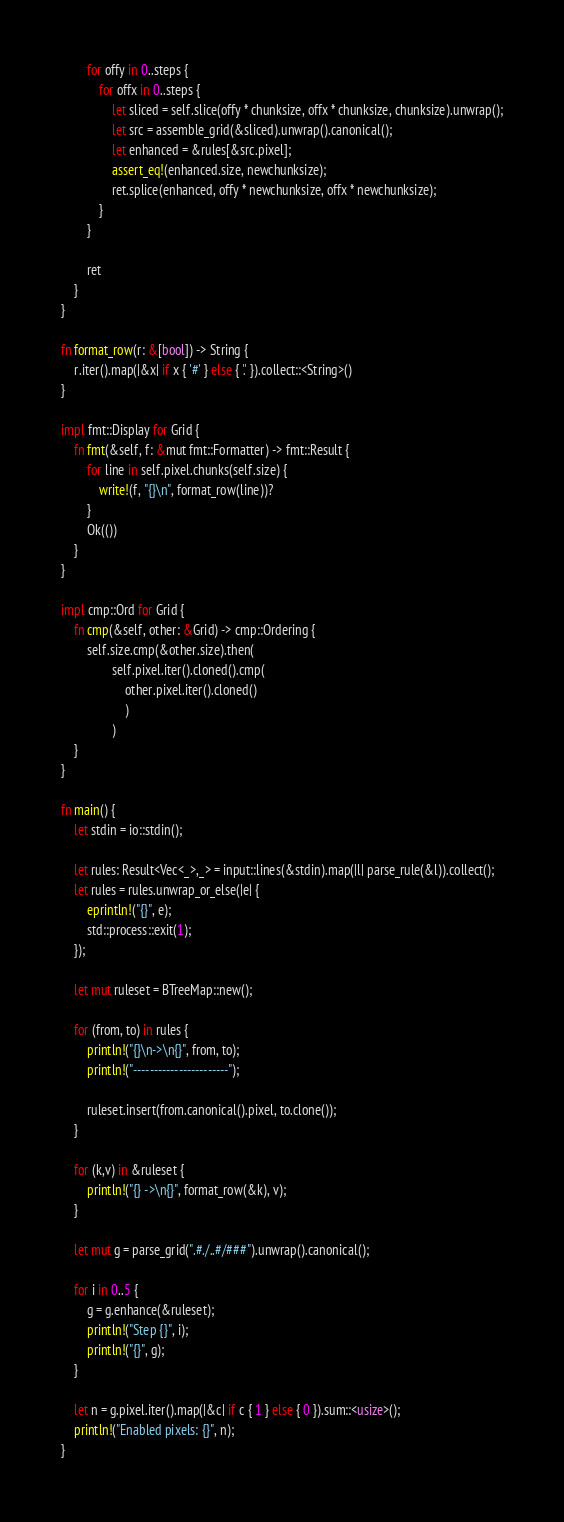<code> <loc_0><loc_0><loc_500><loc_500><_Rust_>
        for offy in 0..steps {
            for offx in 0..steps {
                let sliced = self.slice(offy * chunksize, offx * chunksize, chunksize).unwrap();
                let src = assemble_grid(&sliced).unwrap().canonical();
                let enhanced = &rules[&src.pixel];
                assert_eq!(enhanced.size, newchunksize);
                ret.splice(enhanced, offy * newchunksize, offx * newchunksize);
            }
        }

        ret
    }
}

fn format_row(r: &[bool]) -> String {
    r.iter().map(|&x| if x { '#' } else { '.' }).collect::<String>()
}

impl fmt::Display for Grid {
    fn fmt(&self, f: &mut fmt::Formatter) -> fmt::Result {
        for line in self.pixel.chunks(self.size) {
            write!(f, "{}\n", format_row(line))?
        }
        Ok(())
    }
}

impl cmp::Ord for Grid {
    fn cmp(&self, other: &Grid) -> cmp::Ordering {
        self.size.cmp(&other.size).then(
                self.pixel.iter().cloned().cmp(
                    other.pixel.iter().cloned()
                    )
                )
    }
}

fn main() {
    let stdin = io::stdin();

    let rules: Result<Vec<_>,_> = input::lines(&stdin).map(|l| parse_rule(&l)).collect();
    let rules = rules.unwrap_or_else(|e| {
        eprintln!("{}", e);
        std::process::exit(1);
    });

    let mut ruleset = BTreeMap::new();

    for (from, to) in rules {
        println!("{}\n->\n{}", from, to);
        println!("-----------------------");

        ruleset.insert(from.canonical().pixel, to.clone());
    }

    for (k,v) in &ruleset {
        println!("{} ->\n{}", format_row(&k), v);
    }

    let mut g = parse_grid(".#./..#/###").unwrap().canonical();

    for i in 0..5 {
        g = g.enhance(&ruleset);
        println!("Step {}", i);
        println!("{}", g);
    }

    let n = g.pixel.iter().map(|&c| if c { 1 } else { 0 }).sum::<usize>();
    println!("Enabled pixels: {}", n);
}
</code> 